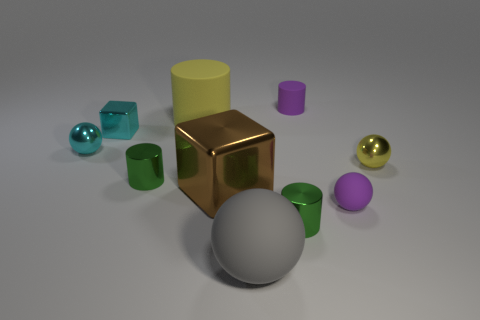Subtract all small purple cylinders. How many cylinders are left? 3 Subtract all yellow spheres. How many spheres are left? 3 Subtract all spheres. How many objects are left? 6 Subtract 3 cylinders. How many cylinders are left? 1 Subtract all yellow cylinders. Subtract all gray spheres. How many cylinders are left? 3 Subtract all blue spheres. How many purple cylinders are left? 1 Subtract all cyan shiny cubes. Subtract all rubber things. How many objects are left? 5 Add 5 big shiny objects. How many big shiny objects are left? 6 Add 7 small matte balls. How many small matte balls exist? 8 Subtract 0 cyan cylinders. How many objects are left? 10 